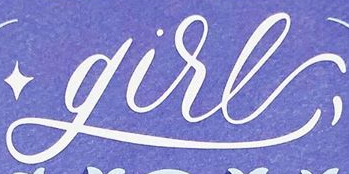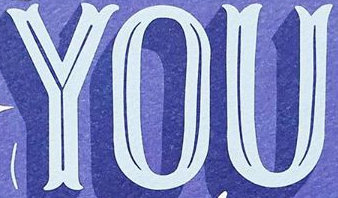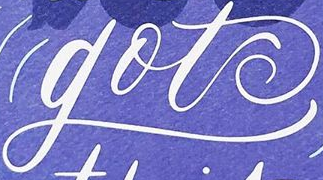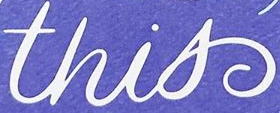What words are shown in these images in order, separated by a semicolon? gire; YOU; got; this 